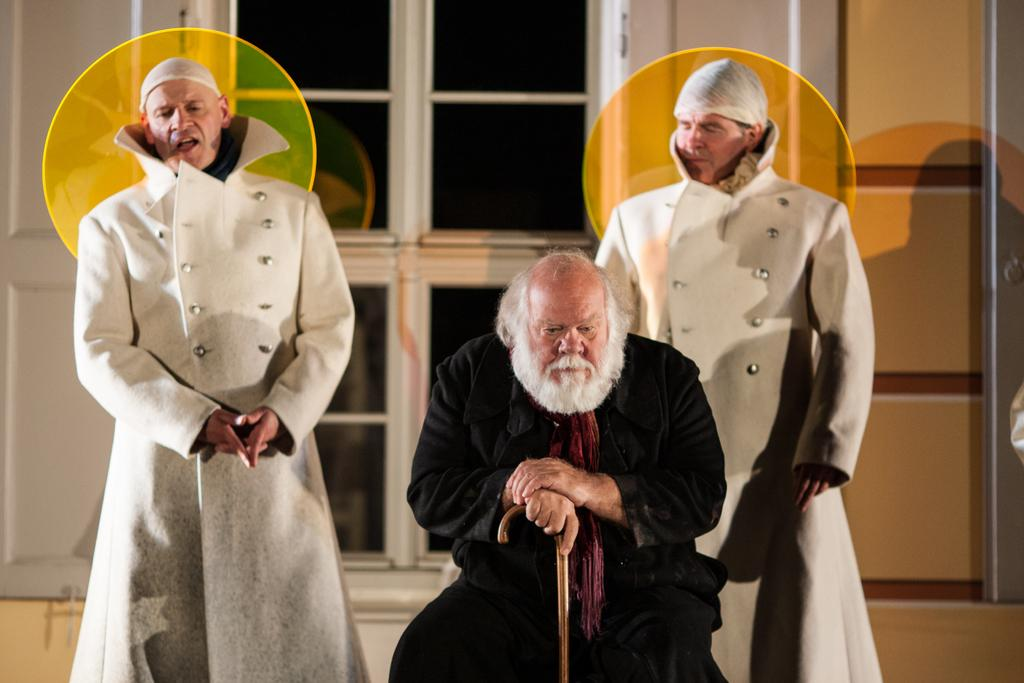What is the man in the image doing? There is a man sitting in the image. What is the man holding? The man is holding a walking stick. How many other people are in the image? There are two men standing in the image. What are the two men wearing? The two men are wearing costumes. What can be seen in the background of the image? There is a window and a wall visible in the image. What type of support does the man use to hold the spoon in the image? There is no spoon present in the image, so there is no support needed for holding one. What kind of jewel can be seen on the costumes of the two men? There are no jewels visible on the costumes of the two men in the image. 